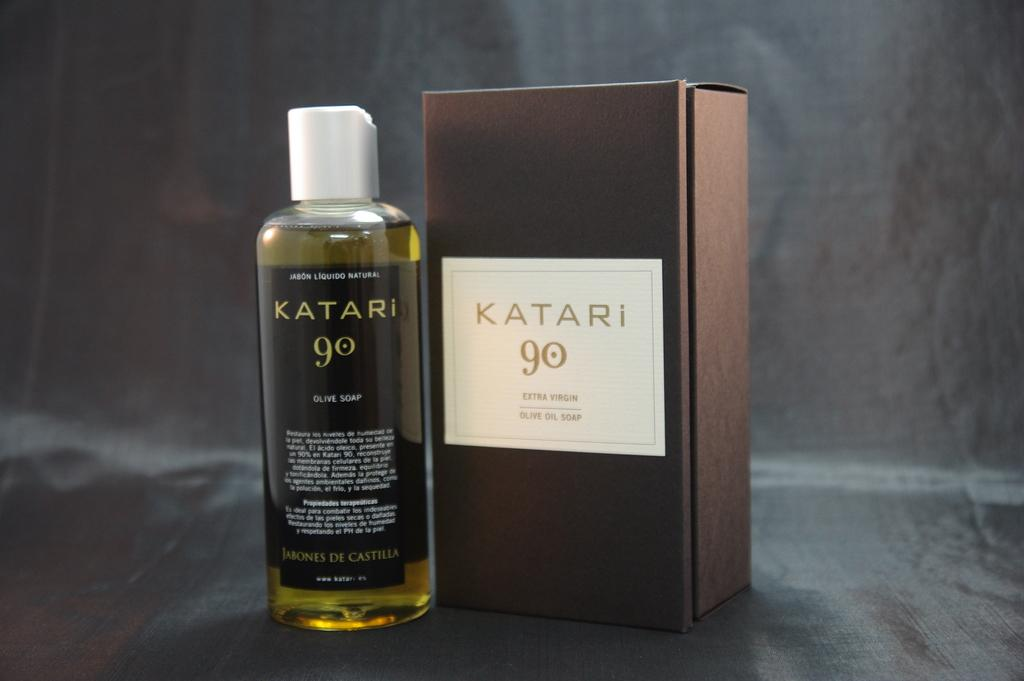<image>
Present a compact description of the photo's key features. Box of Katari 90 and a bottle of Katari 90. 